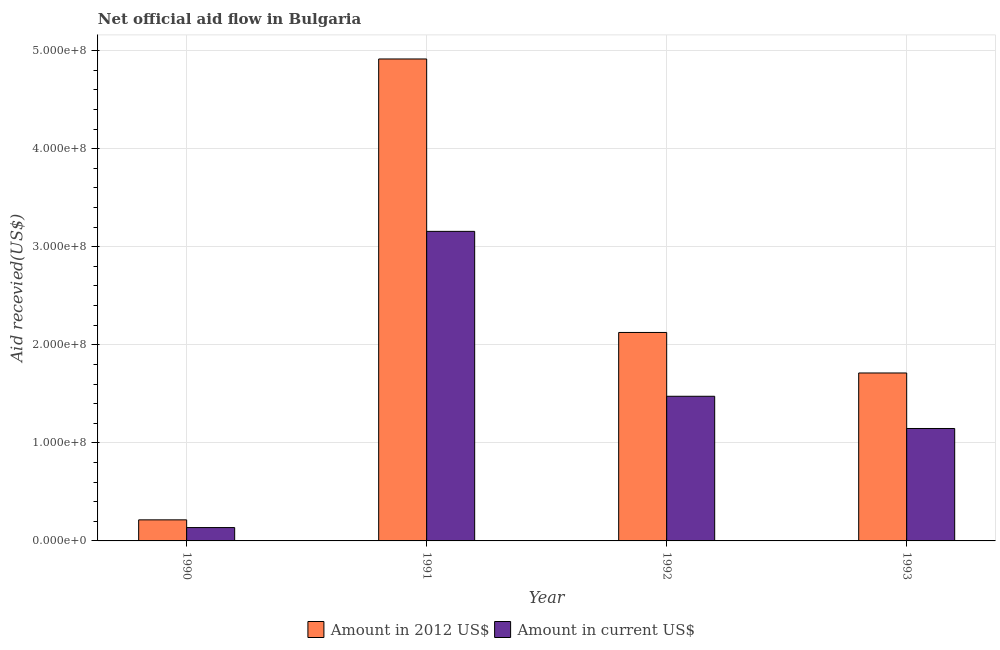How many bars are there on the 2nd tick from the left?
Give a very brief answer. 2. How many bars are there on the 2nd tick from the right?
Your response must be concise. 2. What is the label of the 2nd group of bars from the left?
Your answer should be very brief. 1991. What is the amount of aid received(expressed in us$) in 1990?
Give a very brief answer. 1.36e+07. Across all years, what is the maximum amount of aid received(expressed in 2012 us$)?
Keep it short and to the point. 4.91e+08. Across all years, what is the minimum amount of aid received(expressed in 2012 us$)?
Your answer should be compact. 2.15e+07. What is the total amount of aid received(expressed in us$) in the graph?
Keep it short and to the point. 5.91e+08. What is the difference between the amount of aid received(expressed in 2012 us$) in 1992 and that in 1993?
Give a very brief answer. 4.13e+07. What is the difference between the amount of aid received(expressed in us$) in 1990 and the amount of aid received(expressed in 2012 us$) in 1991?
Keep it short and to the point. -3.02e+08. What is the average amount of aid received(expressed in 2012 us$) per year?
Offer a terse response. 2.24e+08. In the year 1992, what is the difference between the amount of aid received(expressed in us$) and amount of aid received(expressed in 2012 us$)?
Give a very brief answer. 0. What is the ratio of the amount of aid received(expressed in us$) in 1991 to that in 1993?
Your answer should be very brief. 2.75. Is the amount of aid received(expressed in 2012 us$) in 1990 less than that in 1993?
Make the answer very short. Yes. Is the difference between the amount of aid received(expressed in 2012 us$) in 1990 and 1993 greater than the difference between the amount of aid received(expressed in us$) in 1990 and 1993?
Provide a short and direct response. No. What is the difference between the highest and the second highest amount of aid received(expressed in us$)?
Ensure brevity in your answer.  1.68e+08. What is the difference between the highest and the lowest amount of aid received(expressed in 2012 us$)?
Provide a succinct answer. 4.70e+08. What does the 1st bar from the left in 1991 represents?
Give a very brief answer. Amount in 2012 US$. What does the 2nd bar from the right in 1992 represents?
Give a very brief answer. Amount in 2012 US$. How many bars are there?
Offer a very short reply. 8. Are all the bars in the graph horizontal?
Provide a short and direct response. No. How many years are there in the graph?
Provide a succinct answer. 4. What is the difference between two consecutive major ticks on the Y-axis?
Make the answer very short. 1.00e+08. Are the values on the major ticks of Y-axis written in scientific E-notation?
Keep it short and to the point. Yes. Does the graph contain any zero values?
Keep it short and to the point. No. How many legend labels are there?
Provide a short and direct response. 2. What is the title of the graph?
Provide a short and direct response. Net official aid flow in Bulgaria. What is the label or title of the Y-axis?
Your answer should be very brief. Aid recevied(US$). What is the Aid recevied(US$) in Amount in 2012 US$ in 1990?
Your answer should be very brief. 2.15e+07. What is the Aid recevied(US$) of Amount in current US$ in 1990?
Your response must be concise. 1.36e+07. What is the Aid recevied(US$) in Amount in 2012 US$ in 1991?
Provide a short and direct response. 4.91e+08. What is the Aid recevied(US$) of Amount in current US$ in 1991?
Provide a short and direct response. 3.16e+08. What is the Aid recevied(US$) in Amount in 2012 US$ in 1992?
Your answer should be compact. 2.13e+08. What is the Aid recevied(US$) of Amount in current US$ in 1992?
Keep it short and to the point. 1.48e+08. What is the Aid recevied(US$) in Amount in 2012 US$ in 1993?
Your response must be concise. 1.71e+08. What is the Aid recevied(US$) of Amount in current US$ in 1993?
Make the answer very short. 1.15e+08. Across all years, what is the maximum Aid recevied(US$) in Amount in 2012 US$?
Make the answer very short. 4.91e+08. Across all years, what is the maximum Aid recevied(US$) of Amount in current US$?
Make the answer very short. 3.16e+08. Across all years, what is the minimum Aid recevied(US$) in Amount in 2012 US$?
Provide a short and direct response. 2.15e+07. Across all years, what is the minimum Aid recevied(US$) in Amount in current US$?
Your answer should be very brief. 1.36e+07. What is the total Aid recevied(US$) in Amount in 2012 US$ in the graph?
Offer a very short reply. 8.97e+08. What is the total Aid recevied(US$) of Amount in current US$ in the graph?
Ensure brevity in your answer.  5.91e+08. What is the difference between the Aid recevied(US$) in Amount in 2012 US$ in 1990 and that in 1991?
Keep it short and to the point. -4.70e+08. What is the difference between the Aid recevied(US$) in Amount in current US$ in 1990 and that in 1991?
Your response must be concise. -3.02e+08. What is the difference between the Aid recevied(US$) of Amount in 2012 US$ in 1990 and that in 1992?
Your answer should be compact. -1.91e+08. What is the difference between the Aid recevied(US$) of Amount in current US$ in 1990 and that in 1992?
Provide a short and direct response. -1.34e+08. What is the difference between the Aid recevied(US$) in Amount in 2012 US$ in 1990 and that in 1993?
Make the answer very short. -1.50e+08. What is the difference between the Aid recevied(US$) of Amount in current US$ in 1990 and that in 1993?
Ensure brevity in your answer.  -1.01e+08. What is the difference between the Aid recevied(US$) of Amount in 2012 US$ in 1991 and that in 1992?
Your answer should be compact. 2.79e+08. What is the difference between the Aid recevied(US$) in Amount in current US$ in 1991 and that in 1992?
Keep it short and to the point. 1.68e+08. What is the difference between the Aid recevied(US$) of Amount in 2012 US$ in 1991 and that in 1993?
Make the answer very short. 3.20e+08. What is the difference between the Aid recevied(US$) of Amount in current US$ in 1991 and that in 1993?
Make the answer very short. 2.01e+08. What is the difference between the Aid recevied(US$) in Amount in 2012 US$ in 1992 and that in 1993?
Offer a terse response. 4.13e+07. What is the difference between the Aid recevied(US$) in Amount in current US$ in 1992 and that in 1993?
Your response must be concise. 3.29e+07. What is the difference between the Aid recevied(US$) in Amount in 2012 US$ in 1990 and the Aid recevied(US$) in Amount in current US$ in 1991?
Provide a succinct answer. -2.94e+08. What is the difference between the Aid recevied(US$) of Amount in 2012 US$ in 1990 and the Aid recevied(US$) of Amount in current US$ in 1992?
Your response must be concise. -1.26e+08. What is the difference between the Aid recevied(US$) in Amount in 2012 US$ in 1990 and the Aid recevied(US$) in Amount in current US$ in 1993?
Ensure brevity in your answer.  -9.32e+07. What is the difference between the Aid recevied(US$) of Amount in 2012 US$ in 1991 and the Aid recevied(US$) of Amount in current US$ in 1992?
Your answer should be very brief. 3.44e+08. What is the difference between the Aid recevied(US$) in Amount in 2012 US$ in 1991 and the Aid recevied(US$) in Amount in current US$ in 1993?
Your answer should be very brief. 3.77e+08. What is the difference between the Aid recevied(US$) in Amount in 2012 US$ in 1992 and the Aid recevied(US$) in Amount in current US$ in 1993?
Keep it short and to the point. 9.79e+07. What is the average Aid recevied(US$) of Amount in 2012 US$ per year?
Provide a succinct answer. 2.24e+08. What is the average Aid recevied(US$) of Amount in current US$ per year?
Your answer should be very brief. 1.48e+08. In the year 1990, what is the difference between the Aid recevied(US$) of Amount in 2012 US$ and Aid recevied(US$) of Amount in current US$?
Offer a terse response. 7.87e+06. In the year 1991, what is the difference between the Aid recevied(US$) of Amount in 2012 US$ and Aid recevied(US$) of Amount in current US$?
Keep it short and to the point. 1.76e+08. In the year 1992, what is the difference between the Aid recevied(US$) in Amount in 2012 US$ and Aid recevied(US$) in Amount in current US$?
Your answer should be compact. 6.51e+07. In the year 1993, what is the difference between the Aid recevied(US$) of Amount in 2012 US$ and Aid recevied(US$) of Amount in current US$?
Ensure brevity in your answer.  5.66e+07. What is the ratio of the Aid recevied(US$) of Amount in 2012 US$ in 1990 to that in 1991?
Provide a succinct answer. 0.04. What is the ratio of the Aid recevied(US$) in Amount in current US$ in 1990 to that in 1991?
Provide a short and direct response. 0.04. What is the ratio of the Aid recevied(US$) in Amount in 2012 US$ in 1990 to that in 1992?
Offer a very short reply. 0.1. What is the ratio of the Aid recevied(US$) of Amount in current US$ in 1990 to that in 1992?
Your answer should be compact. 0.09. What is the ratio of the Aid recevied(US$) of Amount in 2012 US$ in 1990 to that in 1993?
Offer a very short reply. 0.13. What is the ratio of the Aid recevied(US$) in Amount in current US$ in 1990 to that in 1993?
Your answer should be very brief. 0.12. What is the ratio of the Aid recevied(US$) of Amount in 2012 US$ in 1991 to that in 1992?
Make the answer very short. 2.31. What is the ratio of the Aid recevied(US$) in Amount in current US$ in 1991 to that in 1992?
Ensure brevity in your answer.  2.14. What is the ratio of the Aid recevied(US$) of Amount in 2012 US$ in 1991 to that in 1993?
Make the answer very short. 2.87. What is the ratio of the Aid recevied(US$) of Amount in current US$ in 1991 to that in 1993?
Make the answer very short. 2.75. What is the ratio of the Aid recevied(US$) of Amount in 2012 US$ in 1992 to that in 1993?
Give a very brief answer. 1.24. What is the ratio of the Aid recevied(US$) of Amount in current US$ in 1992 to that in 1993?
Provide a short and direct response. 1.29. What is the difference between the highest and the second highest Aid recevied(US$) of Amount in 2012 US$?
Give a very brief answer. 2.79e+08. What is the difference between the highest and the second highest Aid recevied(US$) in Amount in current US$?
Offer a very short reply. 1.68e+08. What is the difference between the highest and the lowest Aid recevied(US$) in Amount in 2012 US$?
Give a very brief answer. 4.70e+08. What is the difference between the highest and the lowest Aid recevied(US$) in Amount in current US$?
Offer a terse response. 3.02e+08. 